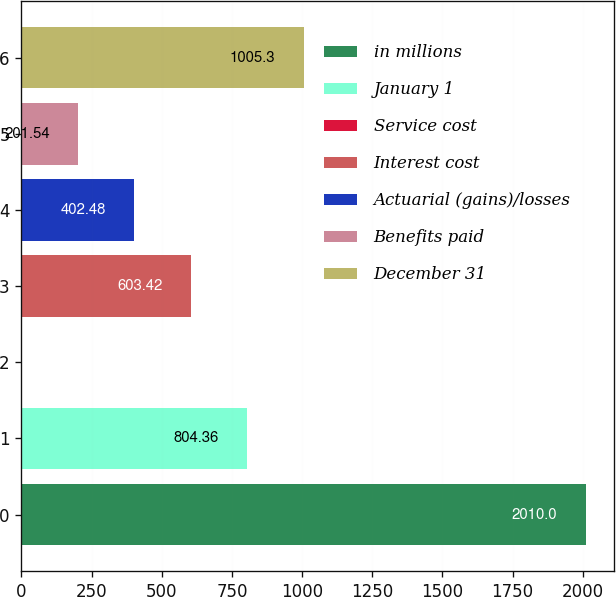<chart> <loc_0><loc_0><loc_500><loc_500><bar_chart><fcel>in millions<fcel>January 1<fcel>Service cost<fcel>Interest cost<fcel>Actuarial (gains)/losses<fcel>Benefits paid<fcel>December 31<nl><fcel>2010<fcel>804.36<fcel>0.6<fcel>603.42<fcel>402.48<fcel>201.54<fcel>1005.3<nl></chart> 